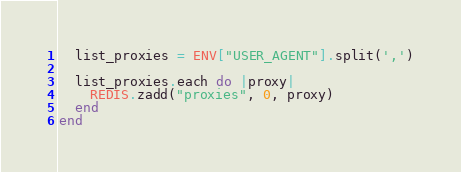<code> <loc_0><loc_0><loc_500><loc_500><_Ruby_>  list_proxies = ENV["USER_AGENT"].split(',')

  list_proxies.each do |proxy|
    REDIS.zadd("proxies", 0, proxy)
  end
end
</code> 